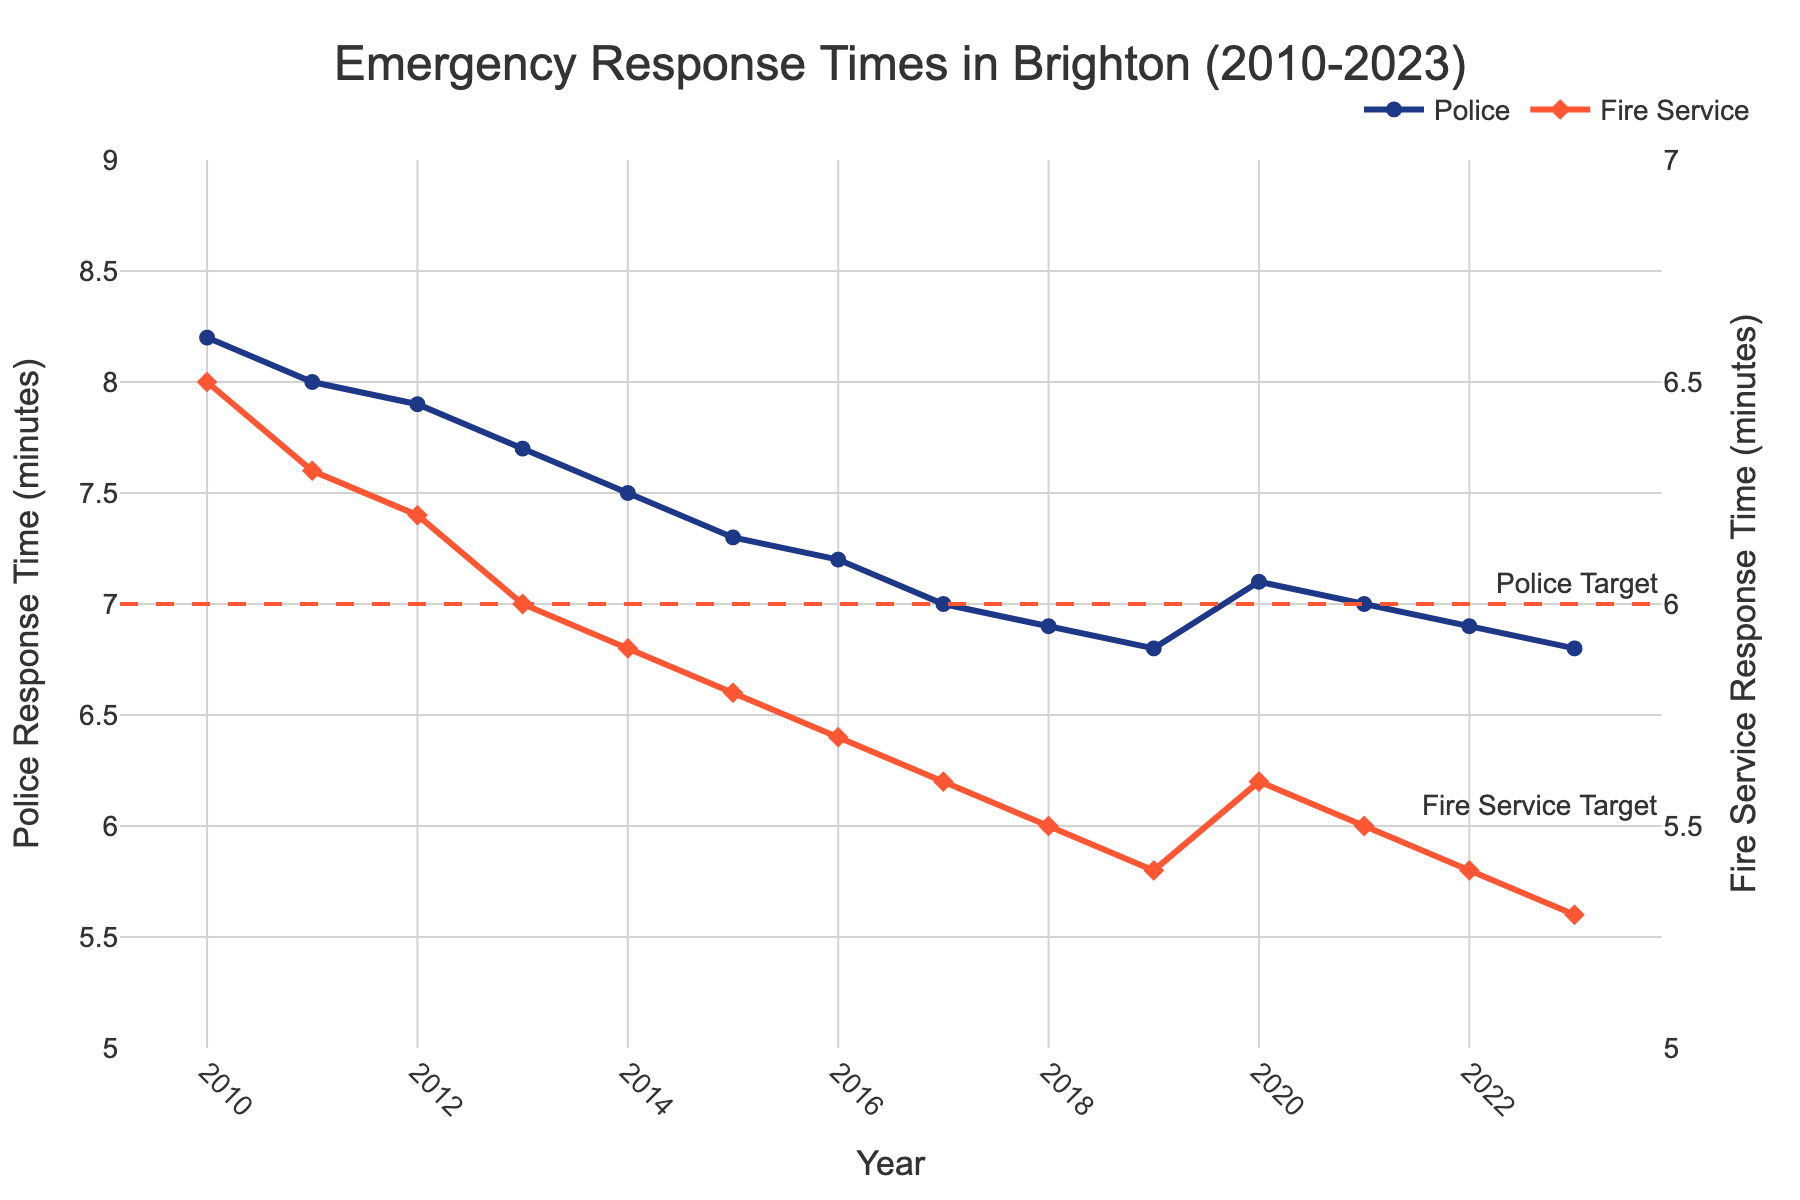what is the overall trend in police response times from 2010 to 2023? Overall trend refers to the general direction in which the data points are moving over time. To determine the trend, observe the data points for police response times from 2010 to 2023. The response times start at 8.2 minutes in 2010 and decrease to 6.8 minutes in 2023.
Answer: Decreasing How does the fire service response time in 2023 compare to the police response time in 2023? Comparison involves checking the values for both services in 2023. The fire service response time is 5.3 minutes, while the police response time is 6.8 minutes. To compare, see which value is larger.
Answer: Fire service response time is lower In which year did the police response time first drop below 7 minutes? To find the year when the police response time first dropped below 7 minutes, look for the first data point value below 7. The data point for the year 2018 shows a response time of 6.9 minutes, which is the first instance below 7 minutes.
Answer: 2018 Compare the response times for police and fire service in 2010. Which one had a faster response time? To compare, look at the data points for the year 2010. The police response time is 8.2 minutes, and the fire service response time is 6.5 minutes. The one with the lower value is faster.
Answer: Fire service What's the average fire service response time between 2010 and 2023? Compute the average by summing up all the fire service response times from 2010 to 2023 and dividing by the number of years. The sum is 6.5+6.3+6.2+6.0+5.9+5.8+5.7+5.6+5.5+5.4+5.6+5.5+5.4+5.3 = 80.7. There are 14 years, so the average is 80.7/14 ≈ 5.764.
Answer: ~5.764 minutes Between which consecutive years did the fire service response times see the largest decrease? The largest decrease can be found by calculating the difference in fire service response times between consecutive years and selecting the maximum value. Check each year's difference: 
2010-2011: 0.2, 2011-2012: 0.1, 2012-2013: 0.2, 2013-2014: 0.1, 2014-2015: 0.1, 2015-2016: 0.1, 2016-2017: 0.1, 2017-2018: 0.1, 2018-2019: 0.1, 2019-2020: -0.2, 2020-2021: 0.1, 2021-2022: 0.1, 2022-2023: 0.1. The largest decrease is between 2019-2020 (-0.2, which is actually an increase), thus between 2019-2020 did not see actual decrease rather increase in response times.
Answer: 2012-2013 How many years did the police response times stay below their target of 7 minutes? To check how many years the police response times stayed below their target, count the years where the police response time is less than 7 minutes. Looking at the data from 2010 to 2023, the years are 2018 to 2023, giving a count of 6 years.
Answer: 6 years Was there any year where both police and fire service response times hit their respective targets at the same time? Check if both the police response time is below 7 minutes and the fire service response time is below 6 minutes in the same year. In 2023, police response time is 6.8 minutes and fire service response time is 5.3 minutes, both meeting the targets.
Answer: Yes, in 2023 What is the maximum difference between police and fire service response times in any given year? Calculate the absolute difference between police and fire service response times for each year and find the maximum. For example, the differences are 8.2-6.5=1.7, 8.0-6.3=1.7, 7.9-6.2=1.7, etc. The maximum difference observed is 1.7 minutes.
Answer: 1.7 minutes Which year saw the lowest police response time, and what was it? Identify the year with the lowest police response time by finding the minimum value in the police response time data. The lowest response time is 6.8 minutes, which occurs in 2019 and 2023.
Answer: 2019 and 2023, 6.8 minutes 